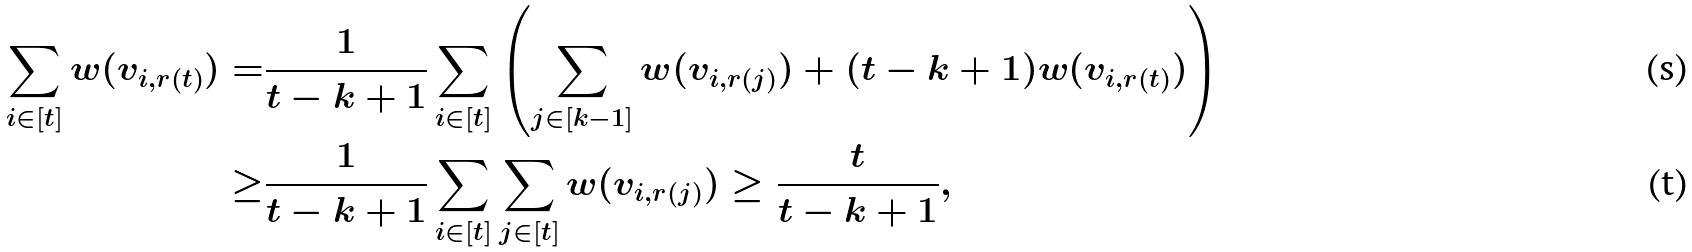<formula> <loc_0><loc_0><loc_500><loc_500>\sum _ { i \in [ t ] } w ( v _ { i , r ( t ) } ) = & \frac { 1 } { t - k + 1 } \sum _ { i \in [ t ] } \left ( \sum _ { j \in [ k - 1 ] } w ( v _ { i , r ( j ) } ) + ( t - k + 1 ) w ( v _ { i , r ( t ) } ) \right ) \\ \geq & \frac { 1 } { t - k + 1 } \sum _ { i \in [ t ] } \sum _ { j \in [ t ] } w ( v _ { i , r ( j ) } ) \geq \frac { t } { t - k + 1 } ,</formula> 